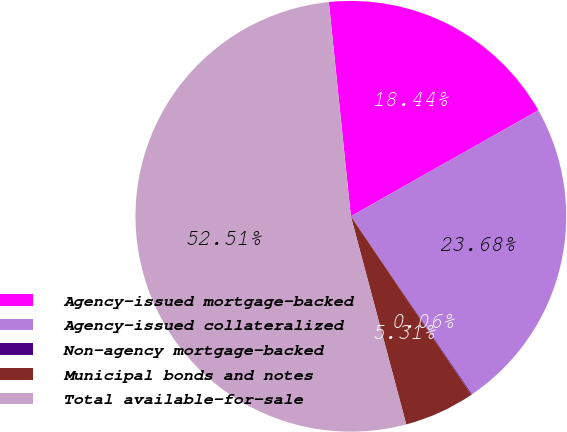Convert chart to OTSL. <chart><loc_0><loc_0><loc_500><loc_500><pie_chart><fcel>Agency-issued mortgage-backed<fcel>Agency-issued collateralized<fcel>Non-agency mortgage-backed<fcel>Municipal bonds and notes<fcel>Total available-for-sale<nl><fcel>18.44%<fcel>23.68%<fcel>0.06%<fcel>5.31%<fcel>52.51%<nl></chart> 